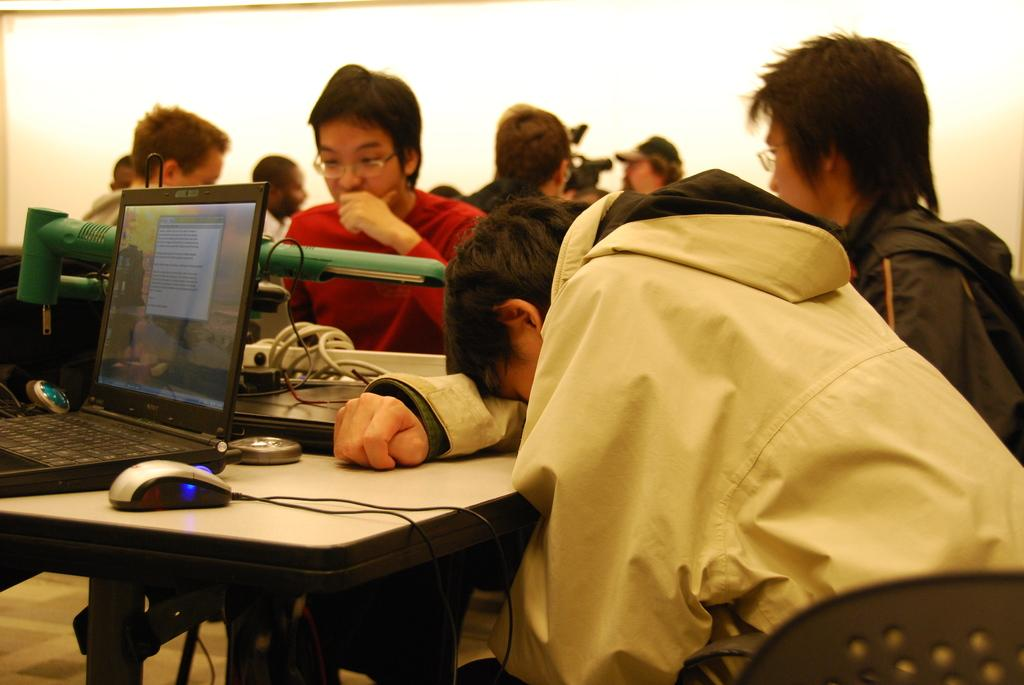What are the people in the image doing? The people in the image are sitting on chairs. What is present on the table in the image? There is a mouse and a laptop on the table. Can you describe the furniture in the image? There is a table and chairs in the image. What type of car is parked outside the window in the image? There is no car or window present in the image. How does the society depicted in the image function? The image does not depict a society, so it is not possible to determine how it functions. 